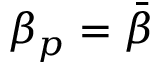Convert formula to latex. <formula><loc_0><loc_0><loc_500><loc_500>\beta _ { p } = \bar { \beta }</formula> 